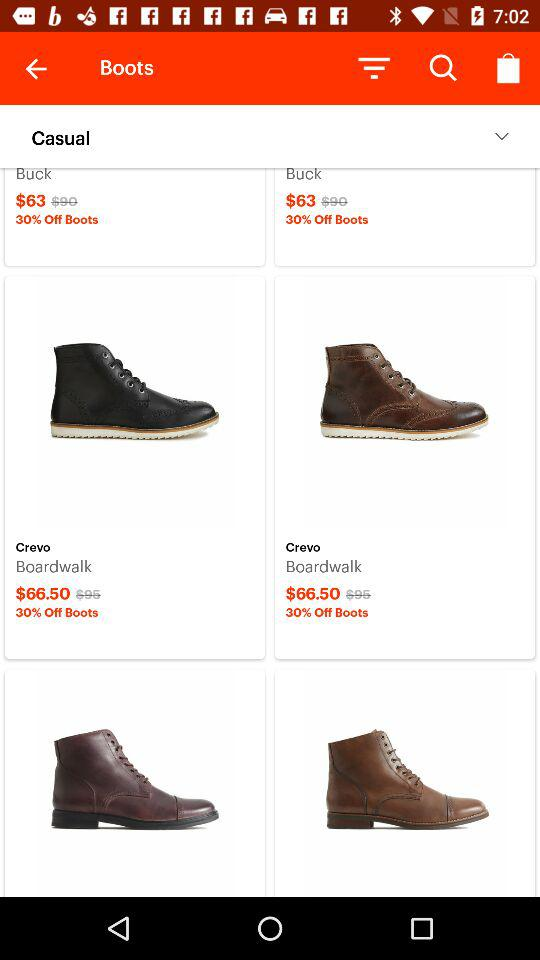What is the discount percent on the buck? The discount percent on buck is 30. 